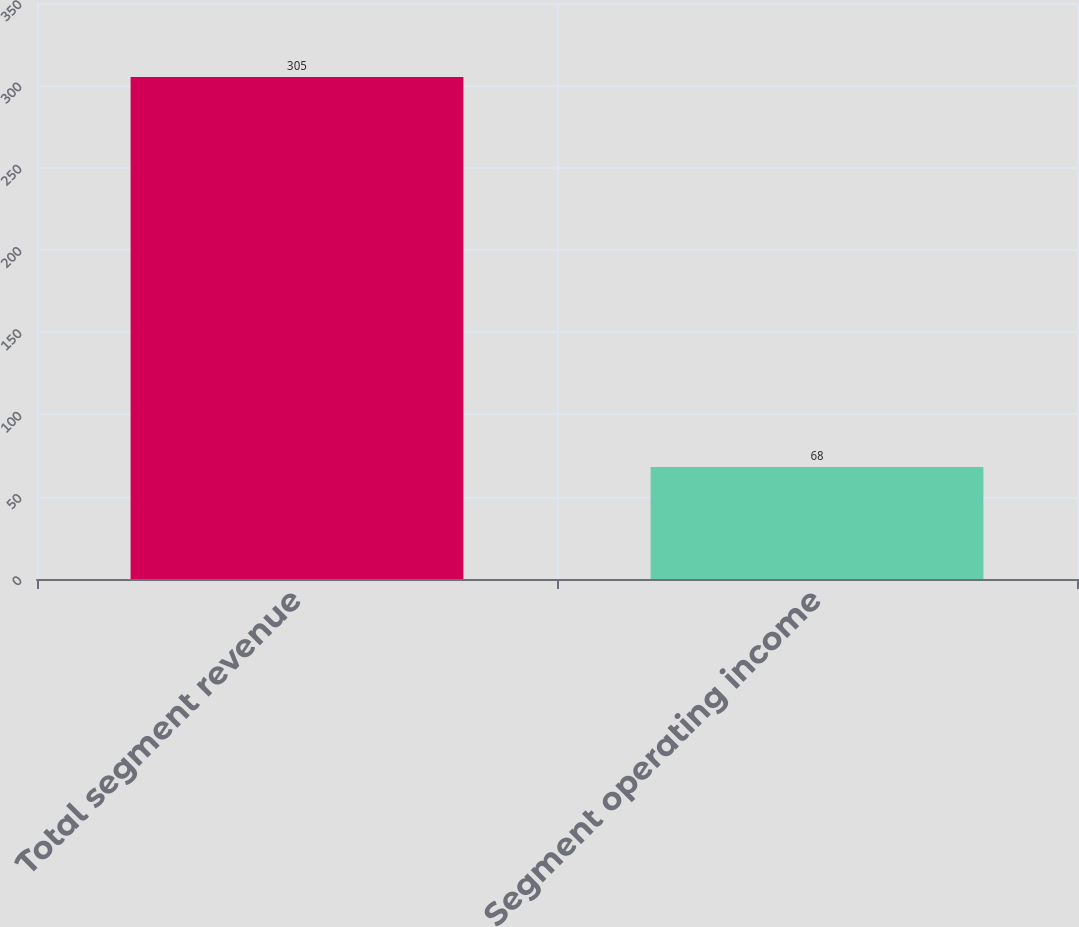<chart> <loc_0><loc_0><loc_500><loc_500><bar_chart><fcel>Total segment revenue<fcel>Segment operating income<nl><fcel>305<fcel>68<nl></chart> 